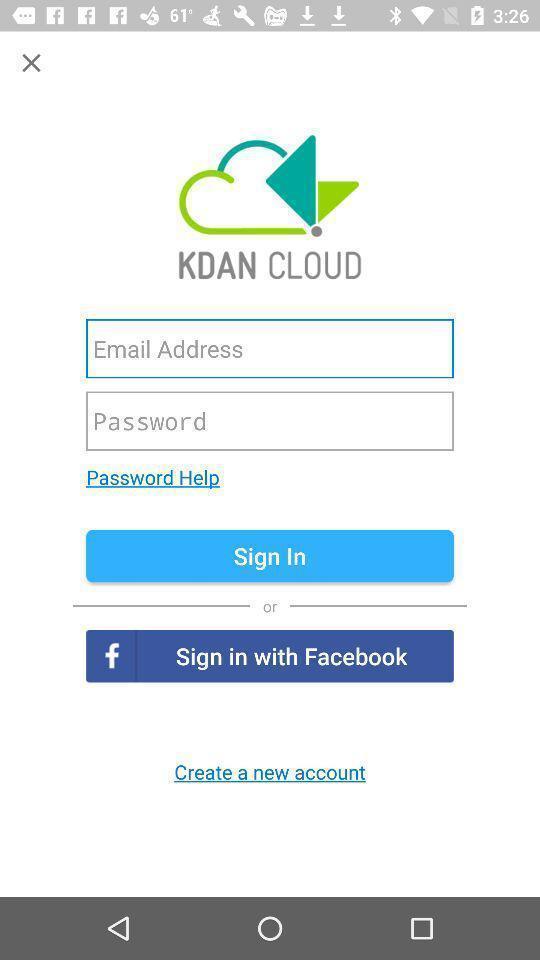Provide a description of this screenshot. Sign-in page. 